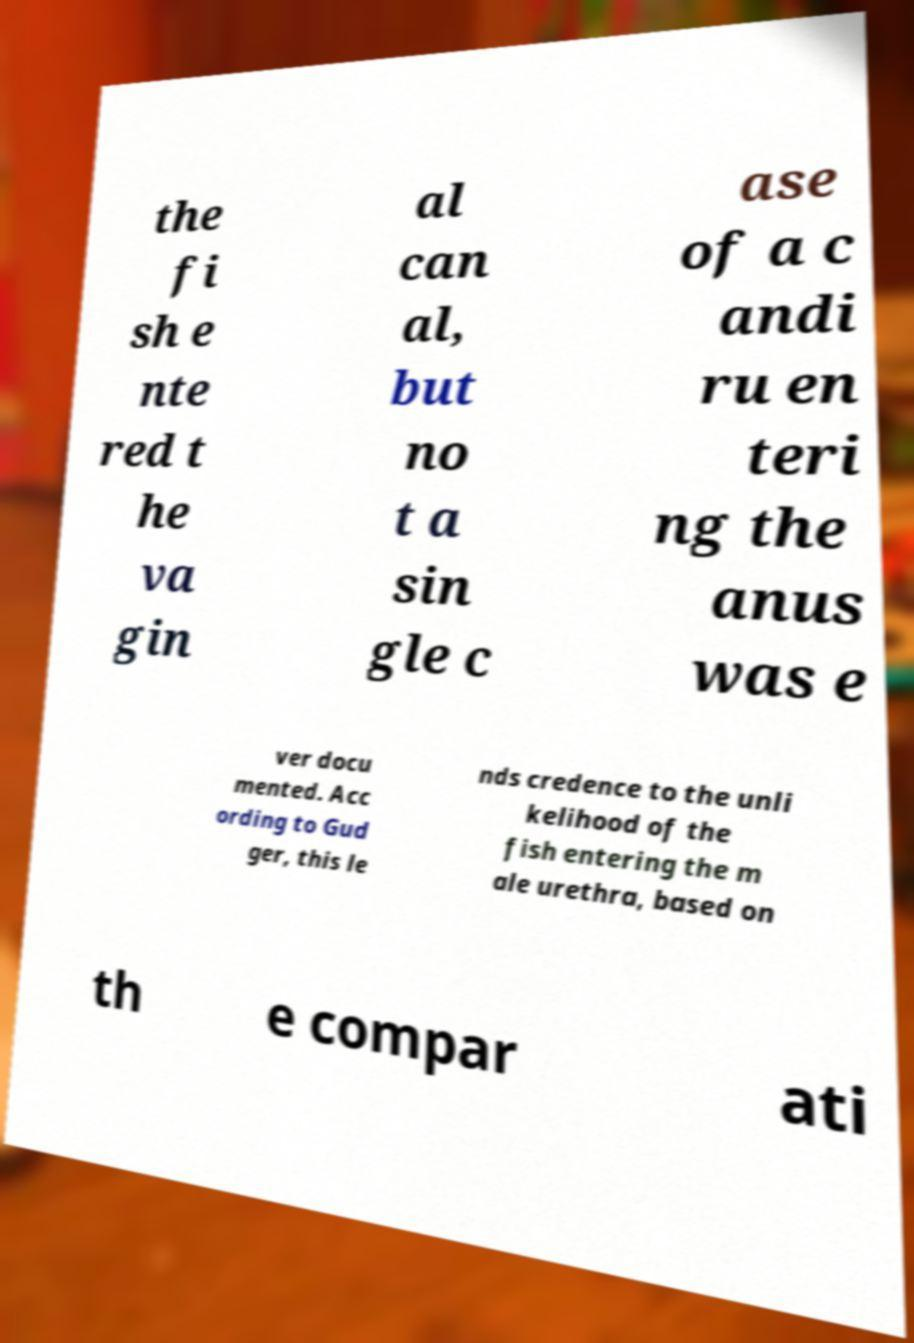For documentation purposes, I need the text within this image transcribed. Could you provide that? the fi sh e nte red t he va gin al can al, but no t a sin gle c ase of a c andi ru en teri ng the anus was e ver docu mented. Acc ording to Gud ger, this le nds credence to the unli kelihood of the fish entering the m ale urethra, based on th e compar ati 